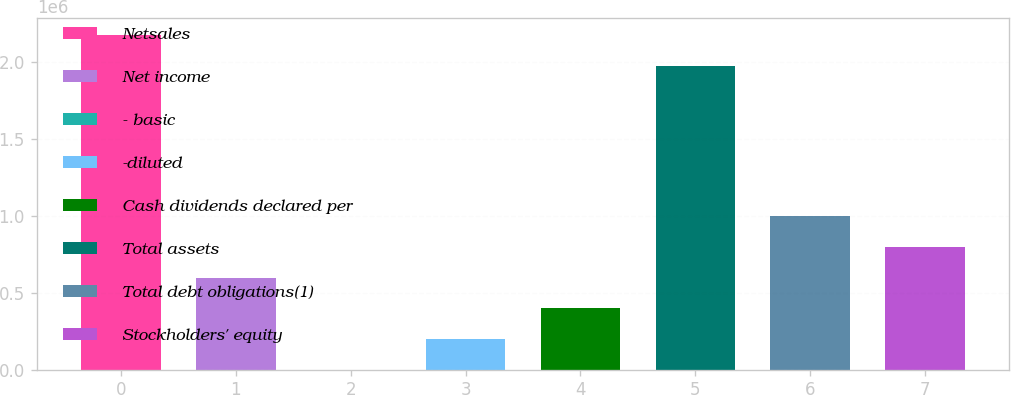Convert chart to OTSL. <chart><loc_0><loc_0><loc_500><loc_500><bar_chart><fcel>Netsales<fcel>Net income<fcel>- basic<fcel>-diluted<fcel>Cash dividends declared per<fcel>Total assets<fcel>Total debt obligations(1)<fcel>Stockholders' equity<nl><fcel>2.17266e+06<fcel>598098<fcel>0.49<fcel>199366<fcel>398732<fcel>1.9733e+06<fcel>996829<fcel>797463<nl></chart> 